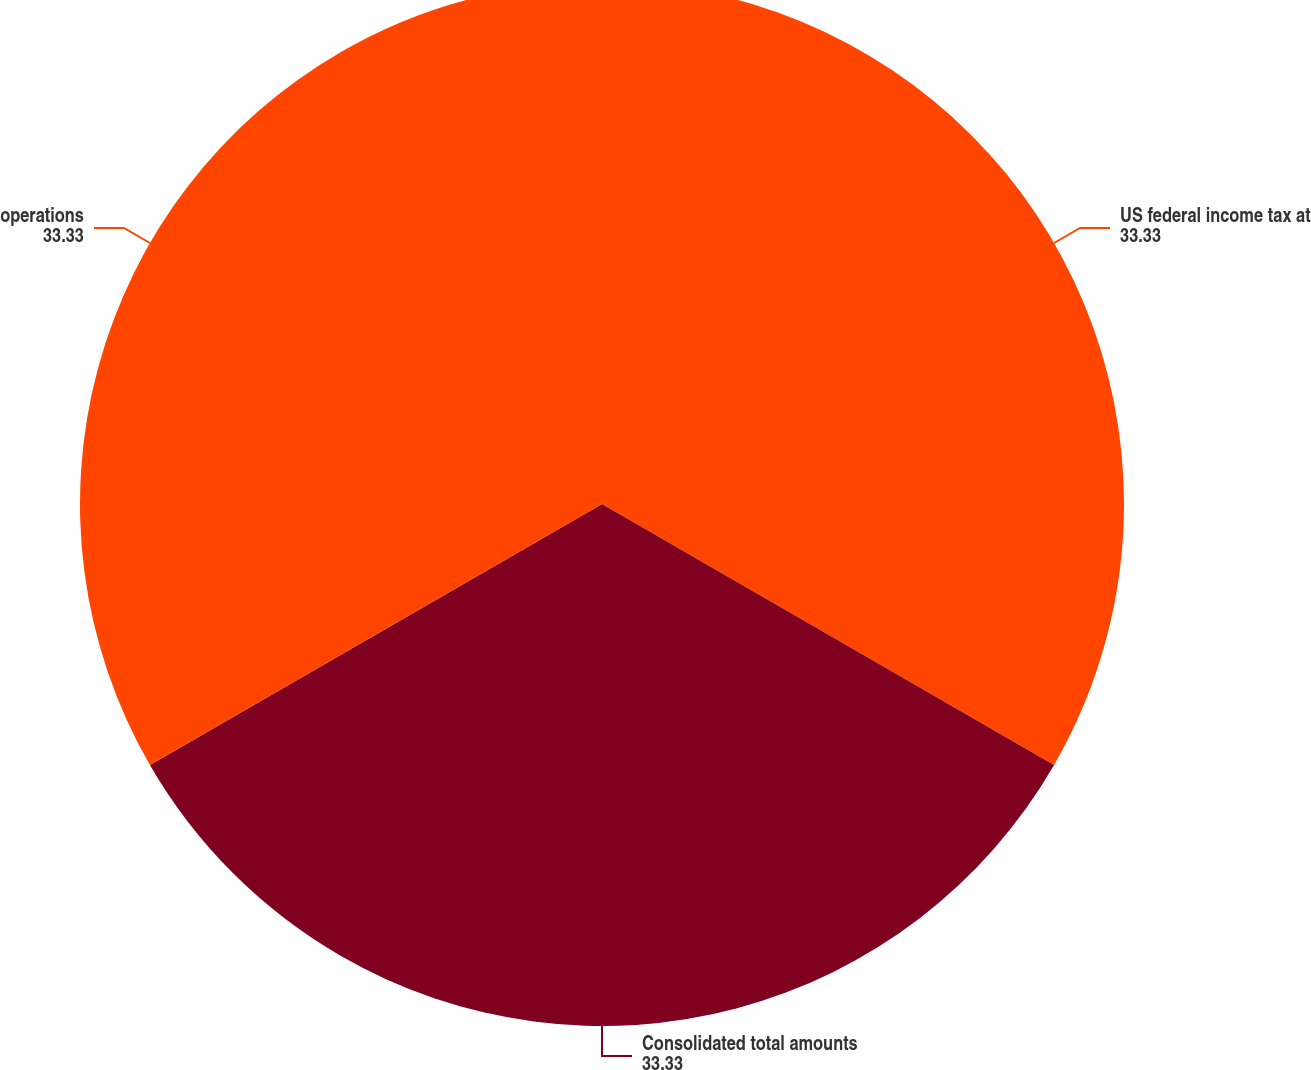<chart> <loc_0><loc_0><loc_500><loc_500><pie_chart><fcel>US federal income tax at<fcel>Consolidated total amounts<fcel>operations<nl><fcel>33.33%<fcel>33.33%<fcel>33.33%<nl></chart> 